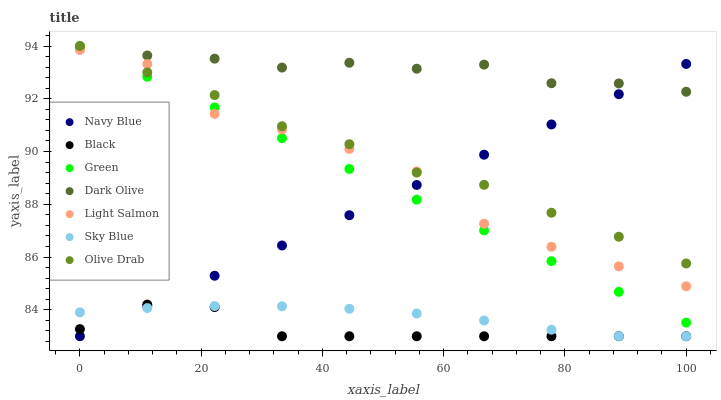Does Black have the minimum area under the curve?
Answer yes or no. Yes. Does Dark Olive have the maximum area under the curve?
Answer yes or no. Yes. Does Navy Blue have the minimum area under the curve?
Answer yes or no. No. Does Navy Blue have the maximum area under the curve?
Answer yes or no. No. Is Green the smoothest?
Answer yes or no. Yes. Is Light Salmon the roughest?
Answer yes or no. Yes. Is Navy Blue the smoothest?
Answer yes or no. No. Is Navy Blue the roughest?
Answer yes or no. No. Does Navy Blue have the lowest value?
Answer yes or no. Yes. Does Dark Olive have the lowest value?
Answer yes or no. No. Does Olive Drab have the highest value?
Answer yes or no. Yes. Does Navy Blue have the highest value?
Answer yes or no. No. Is Black less than Olive Drab?
Answer yes or no. Yes. Is Olive Drab greater than Sky Blue?
Answer yes or no. Yes. Does Dark Olive intersect Green?
Answer yes or no. Yes. Is Dark Olive less than Green?
Answer yes or no. No. Is Dark Olive greater than Green?
Answer yes or no. No. Does Black intersect Olive Drab?
Answer yes or no. No. 